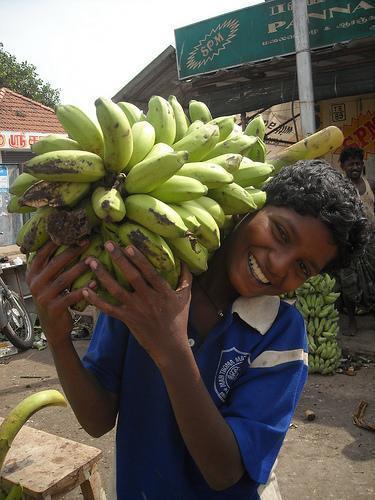How many people are in the picture?
Give a very brief answer. 2. How many people are holding the bananas?
Give a very brief answer. 1. 